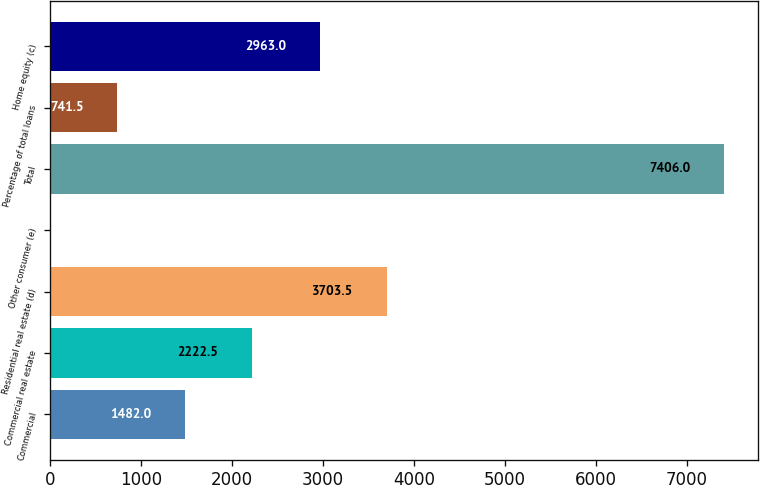Convert chart. <chart><loc_0><loc_0><loc_500><loc_500><bar_chart><fcel>Commercial<fcel>Commercial real estate<fcel>Residential real estate (d)<fcel>Other consumer (e)<fcel>Total<fcel>Percentage of total loans<fcel>Home equity (c)<nl><fcel>1482<fcel>2222.5<fcel>3703.5<fcel>1<fcel>7406<fcel>741.5<fcel>2963<nl></chart> 